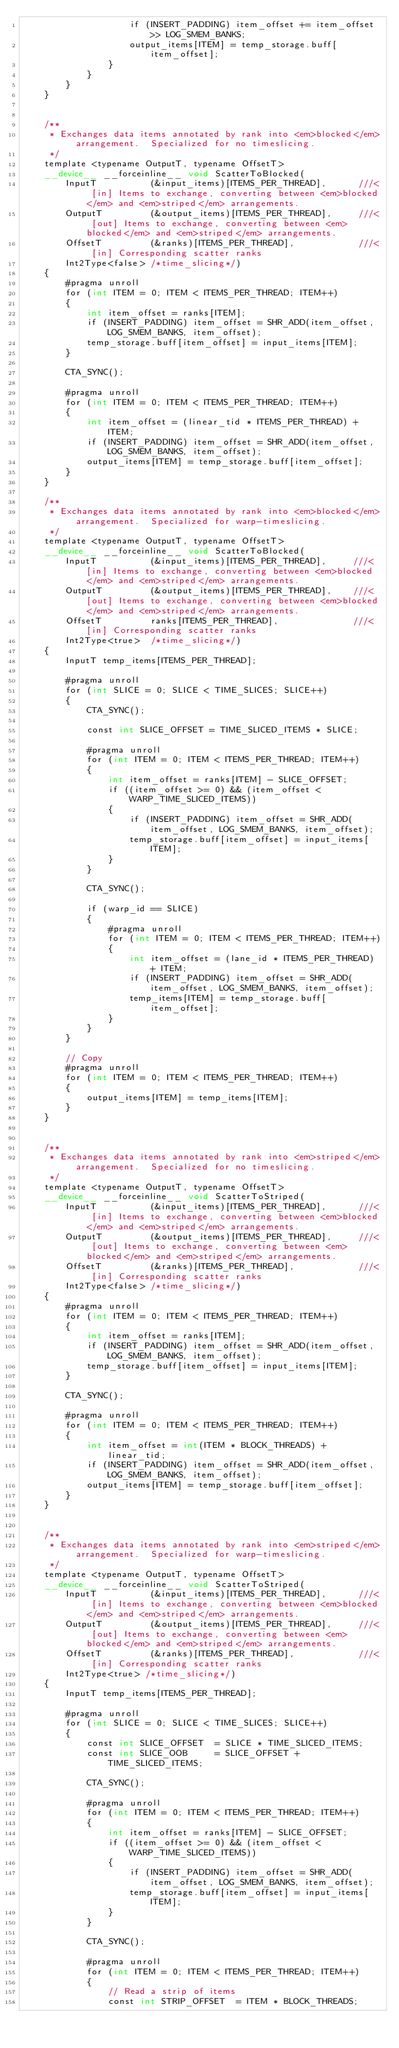Convert code to text. <code><loc_0><loc_0><loc_500><loc_500><_Cuda_>                    if (INSERT_PADDING) item_offset += item_offset >> LOG_SMEM_BANKS;
                    output_items[ITEM] = temp_storage.buff[item_offset];
                }
            }
        }
    }


    /**
     * Exchanges data items annotated by rank into <em>blocked</em> arrangement.  Specialized for no timeslicing.
     */
    template <typename OutputT, typename OffsetT>
    __device__ __forceinline__ void ScatterToBlocked(
        InputT          (&input_items)[ITEMS_PER_THREAD],      ///< [in] Items to exchange, converting between <em>blocked</em> and <em>striped</em> arrangements.
        OutputT         (&output_items)[ITEMS_PER_THREAD],     ///< [out] Items to exchange, converting between <em>blocked</em> and <em>striped</em> arrangements.
        OffsetT         (&ranks)[ITEMS_PER_THREAD],            ///< [in] Corresponding scatter ranks
        Int2Type<false> /*time_slicing*/)
    {
        #pragma unroll
        for (int ITEM = 0; ITEM < ITEMS_PER_THREAD; ITEM++)
        {
            int item_offset = ranks[ITEM];
            if (INSERT_PADDING) item_offset = SHR_ADD(item_offset, LOG_SMEM_BANKS, item_offset);
            temp_storage.buff[item_offset] = input_items[ITEM];
        }

        CTA_SYNC();

        #pragma unroll
        for (int ITEM = 0; ITEM < ITEMS_PER_THREAD; ITEM++)
        {
            int item_offset = (linear_tid * ITEMS_PER_THREAD) + ITEM;
            if (INSERT_PADDING) item_offset = SHR_ADD(item_offset, LOG_SMEM_BANKS, item_offset);
            output_items[ITEM] = temp_storage.buff[item_offset];
        }
    }

    /**
     * Exchanges data items annotated by rank into <em>blocked</em> arrangement.  Specialized for warp-timeslicing.
     */
    template <typename OutputT, typename OffsetT>
    __device__ __forceinline__ void ScatterToBlocked(
        InputT          (&input_items)[ITEMS_PER_THREAD],     ///< [in] Items to exchange, converting between <em>blocked</em> and <em>striped</em> arrangements.
        OutputT         (&output_items)[ITEMS_PER_THREAD],    ///< [out] Items to exchange, converting between <em>blocked</em> and <em>striped</em> arrangements.
        OffsetT         ranks[ITEMS_PER_THREAD],              ///< [in] Corresponding scatter ranks
        Int2Type<true>  /*time_slicing*/)
    {
        InputT temp_items[ITEMS_PER_THREAD];

        #pragma unroll
        for (int SLICE = 0; SLICE < TIME_SLICES; SLICE++)
        {
            CTA_SYNC();

            const int SLICE_OFFSET = TIME_SLICED_ITEMS * SLICE;

            #pragma unroll
            for (int ITEM = 0; ITEM < ITEMS_PER_THREAD; ITEM++)
            {
                int item_offset = ranks[ITEM] - SLICE_OFFSET;
                if ((item_offset >= 0) && (item_offset < WARP_TIME_SLICED_ITEMS))
                {
                    if (INSERT_PADDING) item_offset = SHR_ADD(item_offset, LOG_SMEM_BANKS, item_offset);
                    temp_storage.buff[item_offset] = input_items[ITEM];
                }
            }

            CTA_SYNC();

            if (warp_id == SLICE)
            {
                #pragma unroll
                for (int ITEM = 0; ITEM < ITEMS_PER_THREAD; ITEM++)
                {
                    int item_offset = (lane_id * ITEMS_PER_THREAD) + ITEM;
                    if (INSERT_PADDING) item_offset = SHR_ADD(item_offset, LOG_SMEM_BANKS, item_offset);
                    temp_items[ITEM] = temp_storage.buff[item_offset];
                }
            }
        }

        // Copy
        #pragma unroll
        for (int ITEM = 0; ITEM < ITEMS_PER_THREAD; ITEM++)
        {
            output_items[ITEM] = temp_items[ITEM];
        }
    }


    /**
     * Exchanges data items annotated by rank into <em>striped</em> arrangement.  Specialized for no timeslicing.
     */
    template <typename OutputT, typename OffsetT>
    __device__ __forceinline__ void ScatterToStriped(
        InputT          (&input_items)[ITEMS_PER_THREAD],      ///< [in] Items to exchange, converting between <em>blocked</em> and <em>striped</em> arrangements.
        OutputT         (&output_items)[ITEMS_PER_THREAD],     ///< [out] Items to exchange, converting between <em>blocked</em> and <em>striped</em> arrangements.
        OffsetT         (&ranks)[ITEMS_PER_THREAD],            ///< [in] Corresponding scatter ranks
        Int2Type<false> /*time_slicing*/)
    {
        #pragma unroll
        for (int ITEM = 0; ITEM < ITEMS_PER_THREAD; ITEM++)
        {
            int item_offset = ranks[ITEM];
            if (INSERT_PADDING) item_offset = SHR_ADD(item_offset, LOG_SMEM_BANKS, item_offset);
            temp_storage.buff[item_offset] = input_items[ITEM];
        }

        CTA_SYNC();

        #pragma unroll
        for (int ITEM = 0; ITEM < ITEMS_PER_THREAD; ITEM++)
        {
            int item_offset = int(ITEM * BLOCK_THREADS) + linear_tid;
            if (INSERT_PADDING) item_offset = SHR_ADD(item_offset, LOG_SMEM_BANKS, item_offset);
            output_items[ITEM] = temp_storage.buff[item_offset];
        }
    }


    /**
     * Exchanges data items annotated by rank into <em>striped</em> arrangement.  Specialized for warp-timeslicing.
     */
    template <typename OutputT, typename OffsetT>
    __device__ __forceinline__ void ScatterToStriped(
        InputT          (&input_items)[ITEMS_PER_THREAD],      ///< [in] Items to exchange, converting between <em>blocked</em> and <em>striped</em> arrangements.
        OutputT         (&output_items)[ITEMS_PER_THREAD],     ///< [out] Items to exchange, converting between <em>blocked</em> and <em>striped</em> arrangements.
        OffsetT         (&ranks)[ITEMS_PER_THREAD],            ///< [in] Corresponding scatter ranks
        Int2Type<true> /*time_slicing*/)
    {
        InputT temp_items[ITEMS_PER_THREAD];

        #pragma unroll
        for (int SLICE = 0; SLICE < TIME_SLICES; SLICE++)
        {
            const int SLICE_OFFSET  = SLICE * TIME_SLICED_ITEMS;
            const int SLICE_OOB     = SLICE_OFFSET + TIME_SLICED_ITEMS;

            CTA_SYNC();

            #pragma unroll
            for (int ITEM = 0; ITEM < ITEMS_PER_THREAD; ITEM++)
            {
                int item_offset = ranks[ITEM] - SLICE_OFFSET;
                if ((item_offset >= 0) && (item_offset < WARP_TIME_SLICED_ITEMS))
                {
                    if (INSERT_PADDING) item_offset = SHR_ADD(item_offset, LOG_SMEM_BANKS, item_offset);
                    temp_storage.buff[item_offset] = input_items[ITEM];
                }
            }

            CTA_SYNC();

            #pragma unroll
            for (int ITEM = 0; ITEM < ITEMS_PER_THREAD; ITEM++)
            {
                // Read a strip of items
                const int STRIP_OFFSET  = ITEM * BLOCK_THREADS;</code> 